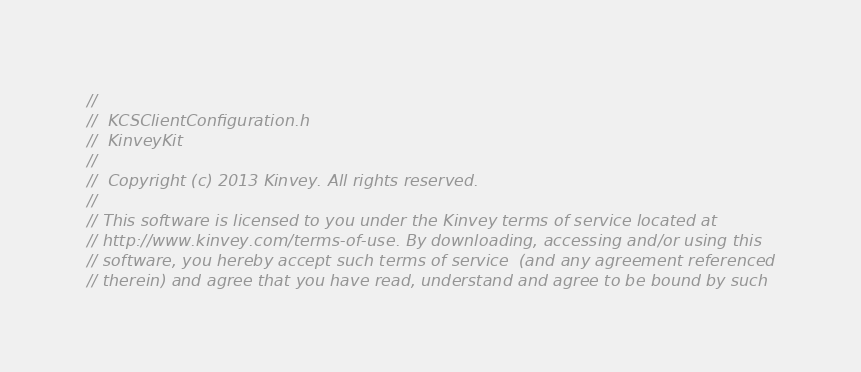<code> <loc_0><loc_0><loc_500><loc_500><_C_>//
//  KCSClientConfiguration.h
//  KinveyKit
//
//  Copyright (c) 2013 Kinvey. All rights reserved.
//
// This software is licensed to you under the Kinvey terms of service located at
// http://www.kinvey.com/terms-of-use. By downloading, accessing and/or using this
// software, you hereby accept such terms of service  (and any agreement referenced
// therein) and agree that you have read, understand and agree to be bound by such</code> 